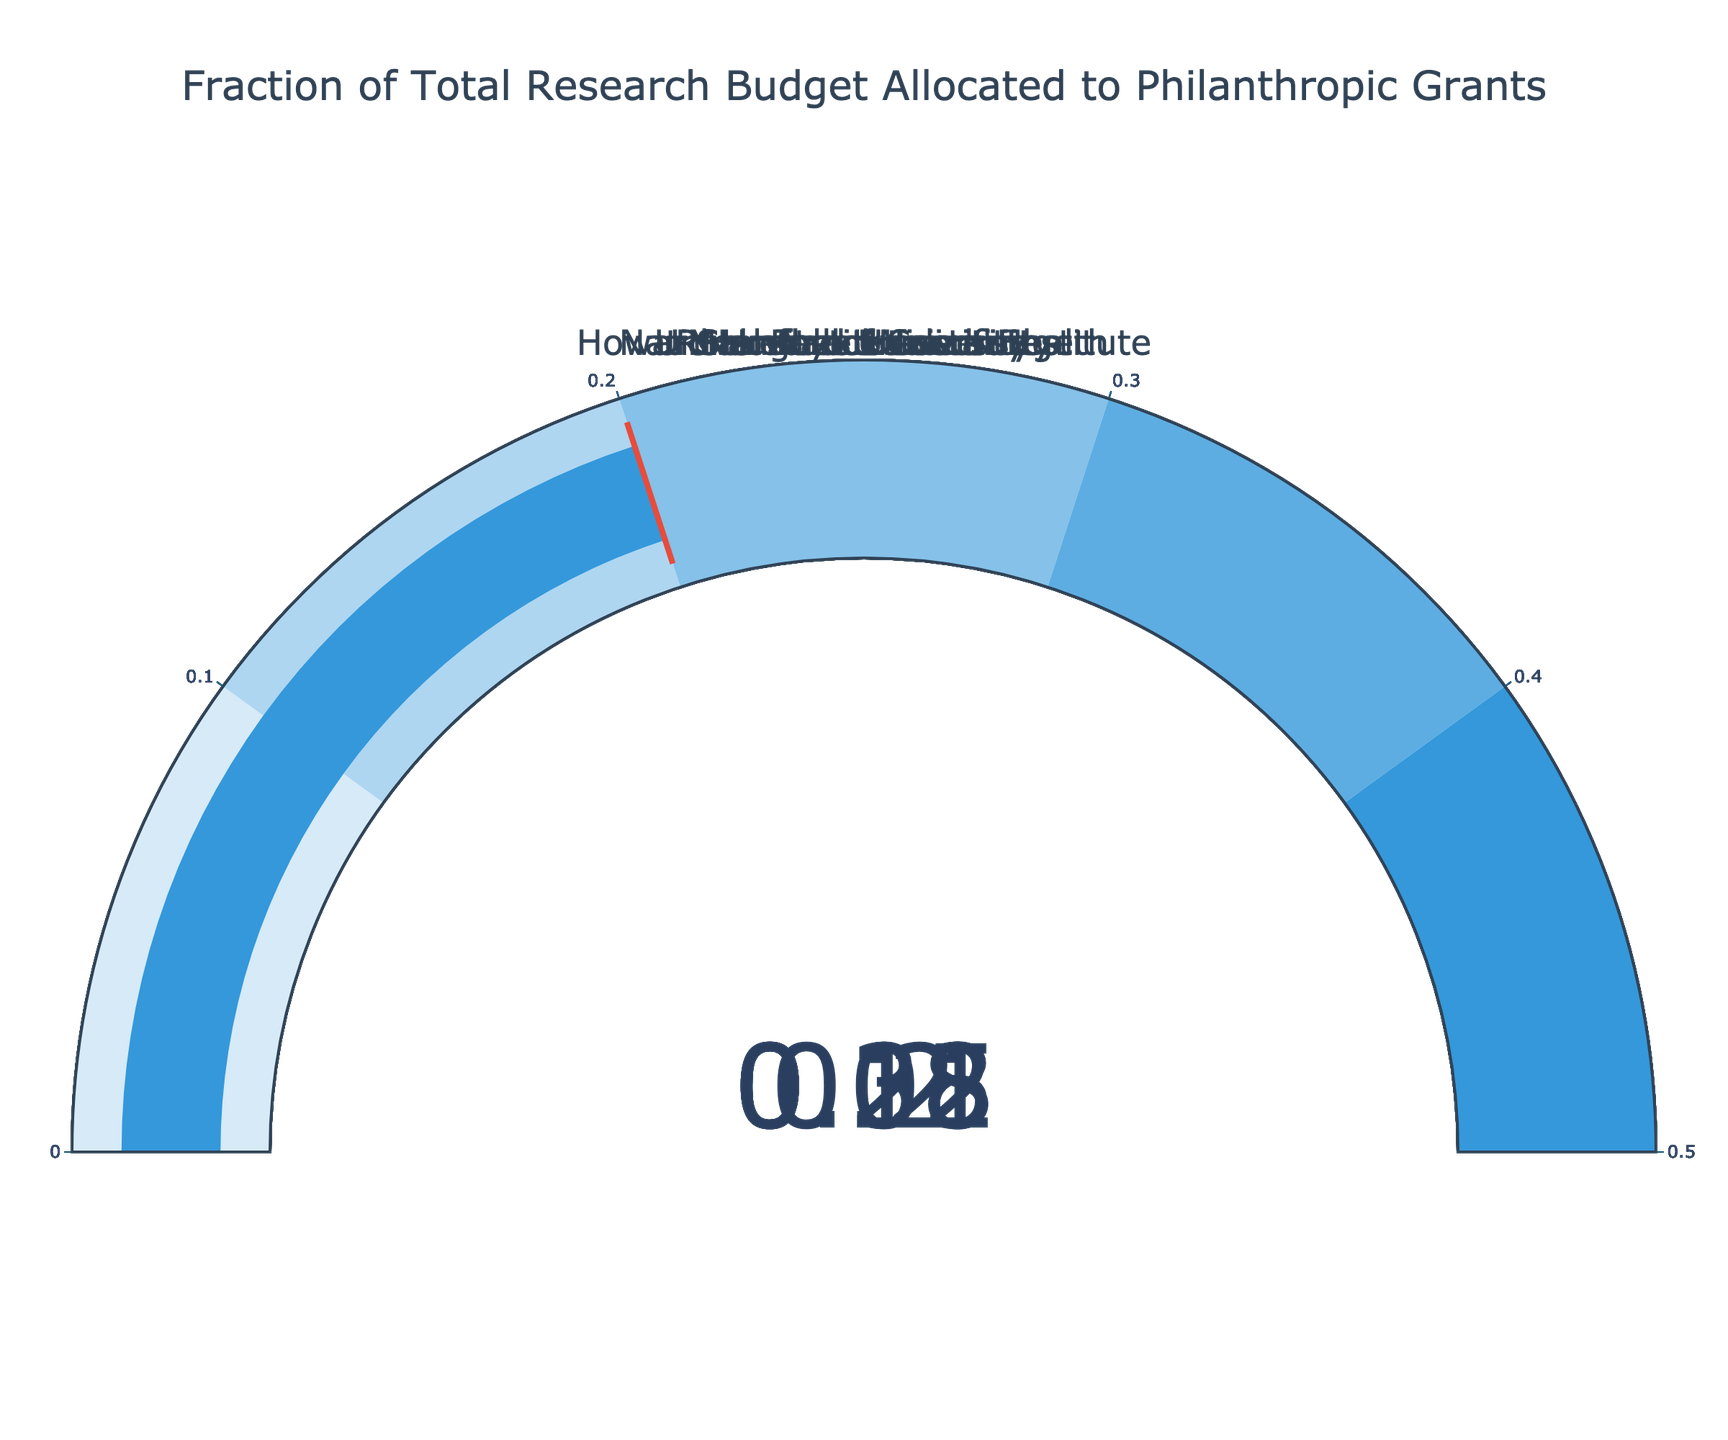What's the highest fraction allocated to philanthropic grants among the institutions? By looking at the gauge charts, we identify the highest value represented on the scales. The Howard Hughes Medical Institute shows the highest fraction at 0.31.
Answer: 0.31 Which institution allocates the smallest fraction of its budget to philanthropic grants? By examining each gauge, the National Institutes of Health has the lowest value at 0.08.
Answer: National Institutes of Health What is the average fraction of the budget allocated to philanthropic grants across all institutions? Add all the values: 0.15 + 0.08 + 0.22 + 0.31 + 0.12 + 0.18 + 0.20, which equals 1.26. Then, divide by the number of institutions (7): 1.26 / 7 ≈ 0.18.
Answer: 0.18 How does Stanford University compare to the University of Cambridge in terms of budget allocation to philanthropic grants? Stanford University allocates 0.15 and the University of Cambridge allocates 0.18 to philanthropic grants. Therefore, Cambridge has a higher allocation.
Answer: University of Cambridge allocates more Which institutions have a fraction of the budget allocated to philanthropic grants greater than 0.2? Looking at the charts, Rockefeller University (0.22), Howard Hughes Medical Institute (0.31), and Harvard University (0.20) are above 0.2.
Answer: Rockefeller University, Howard Hughes Medical Institute, Harvard University What is the difference in philanthropic budget fraction between Max Planck Institute and Harvard University? Harvard University allocates 0.20, while Max Planck Institute allocates 0.12. The difference is 0.20 - 0.12 which equals 0.08.
Answer: 0.08 How many institutions have their budget fraction within the range 0.1 to 0.2? Examining the gauges, the institutions in this range are Stanford University (0.15), National Institutes of Health (0.08), Max Planck Institute (0.12), and University of Cambridge (0.18). There are 4 institutions.
Answer: 4 If we consider the threshold indicated in the gauge, how many institutions meet or exceed their threshold setting? Each gauge shows a threshold line at the fraction value itself. Thus, all institutions meet this threshold.
Answer: All Which institution has the second highest allocation to philanthropic grants? From the gauge charts, Howard Hughes Medical Institute has the highest at 0.31. The next highest is Rockefeller University with 0.22.
Answer: Rockefeller University 